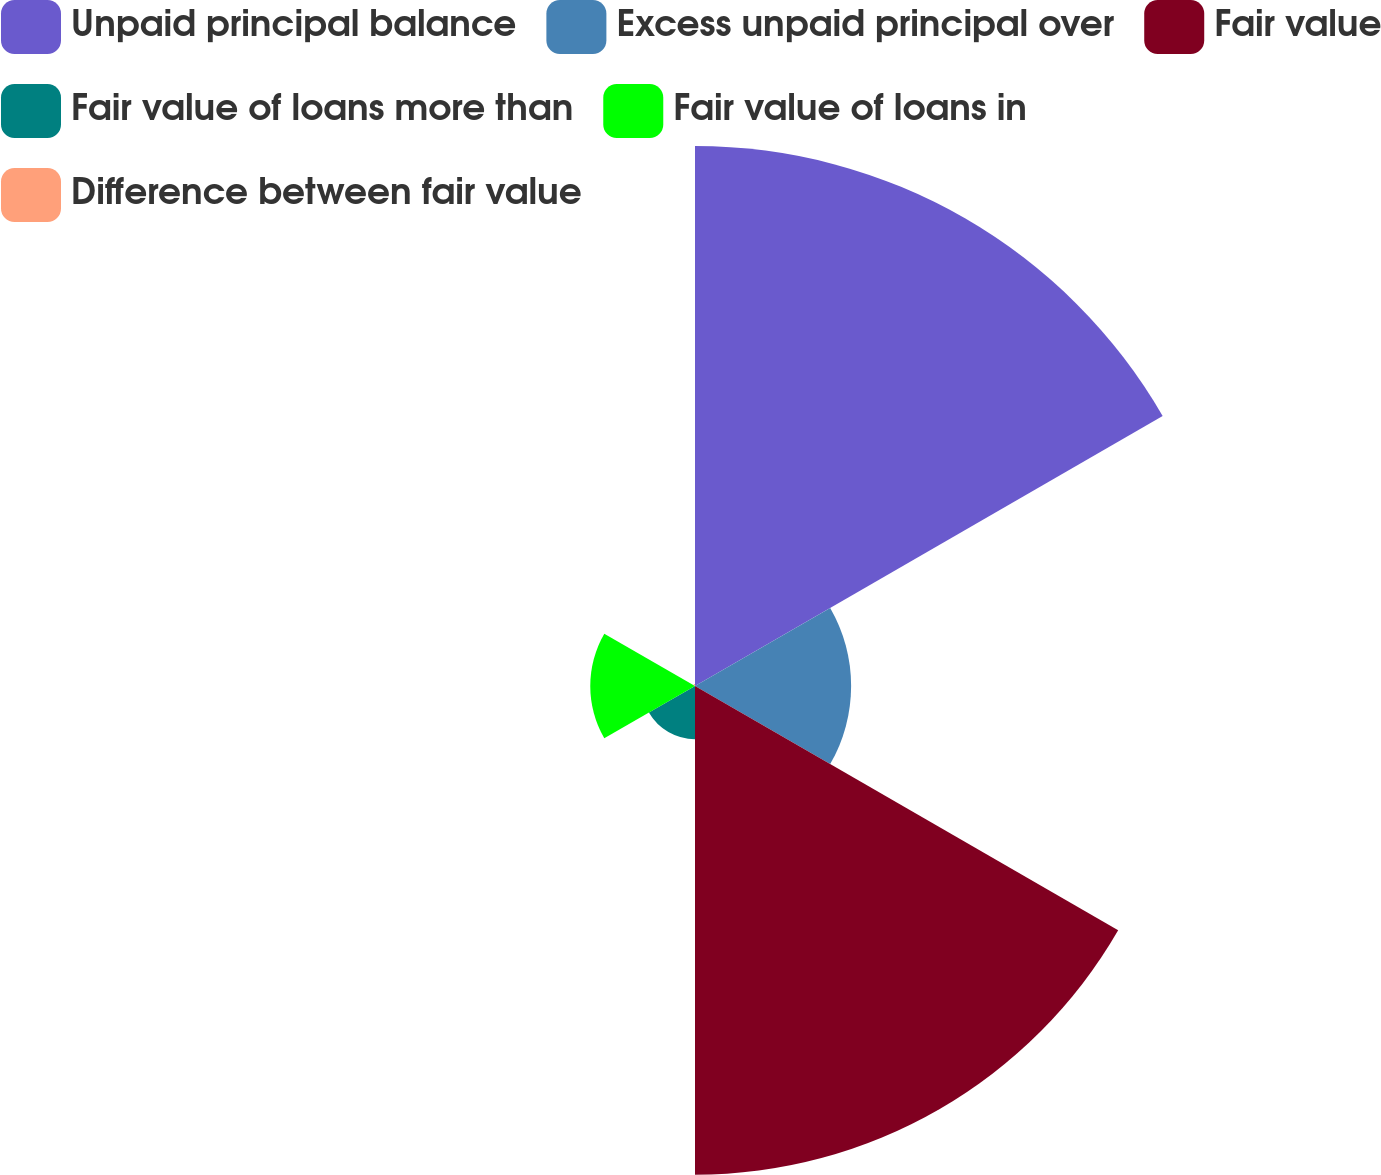Convert chart to OTSL. <chart><loc_0><loc_0><loc_500><loc_500><pie_chart><fcel>Unpaid principal balance<fcel>Excess unpaid principal over<fcel>Fair value<fcel>Fair value of loans more than<fcel>Fair value of loans in<fcel>Difference between fair value<nl><fcel>40.16%<fcel>11.61%<fcel>36.34%<fcel>3.96%<fcel>7.79%<fcel>0.14%<nl></chart> 